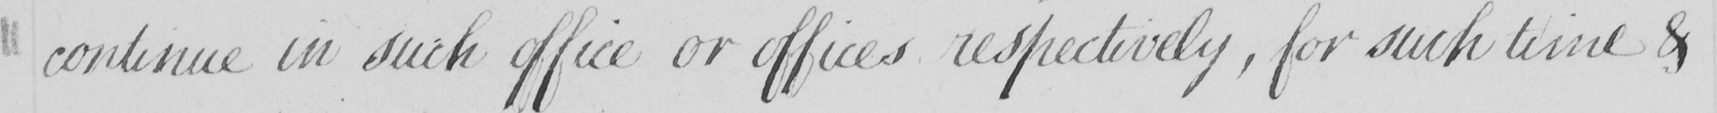What is written in this line of handwriting? continue in such office or offices respectively , for such time & 